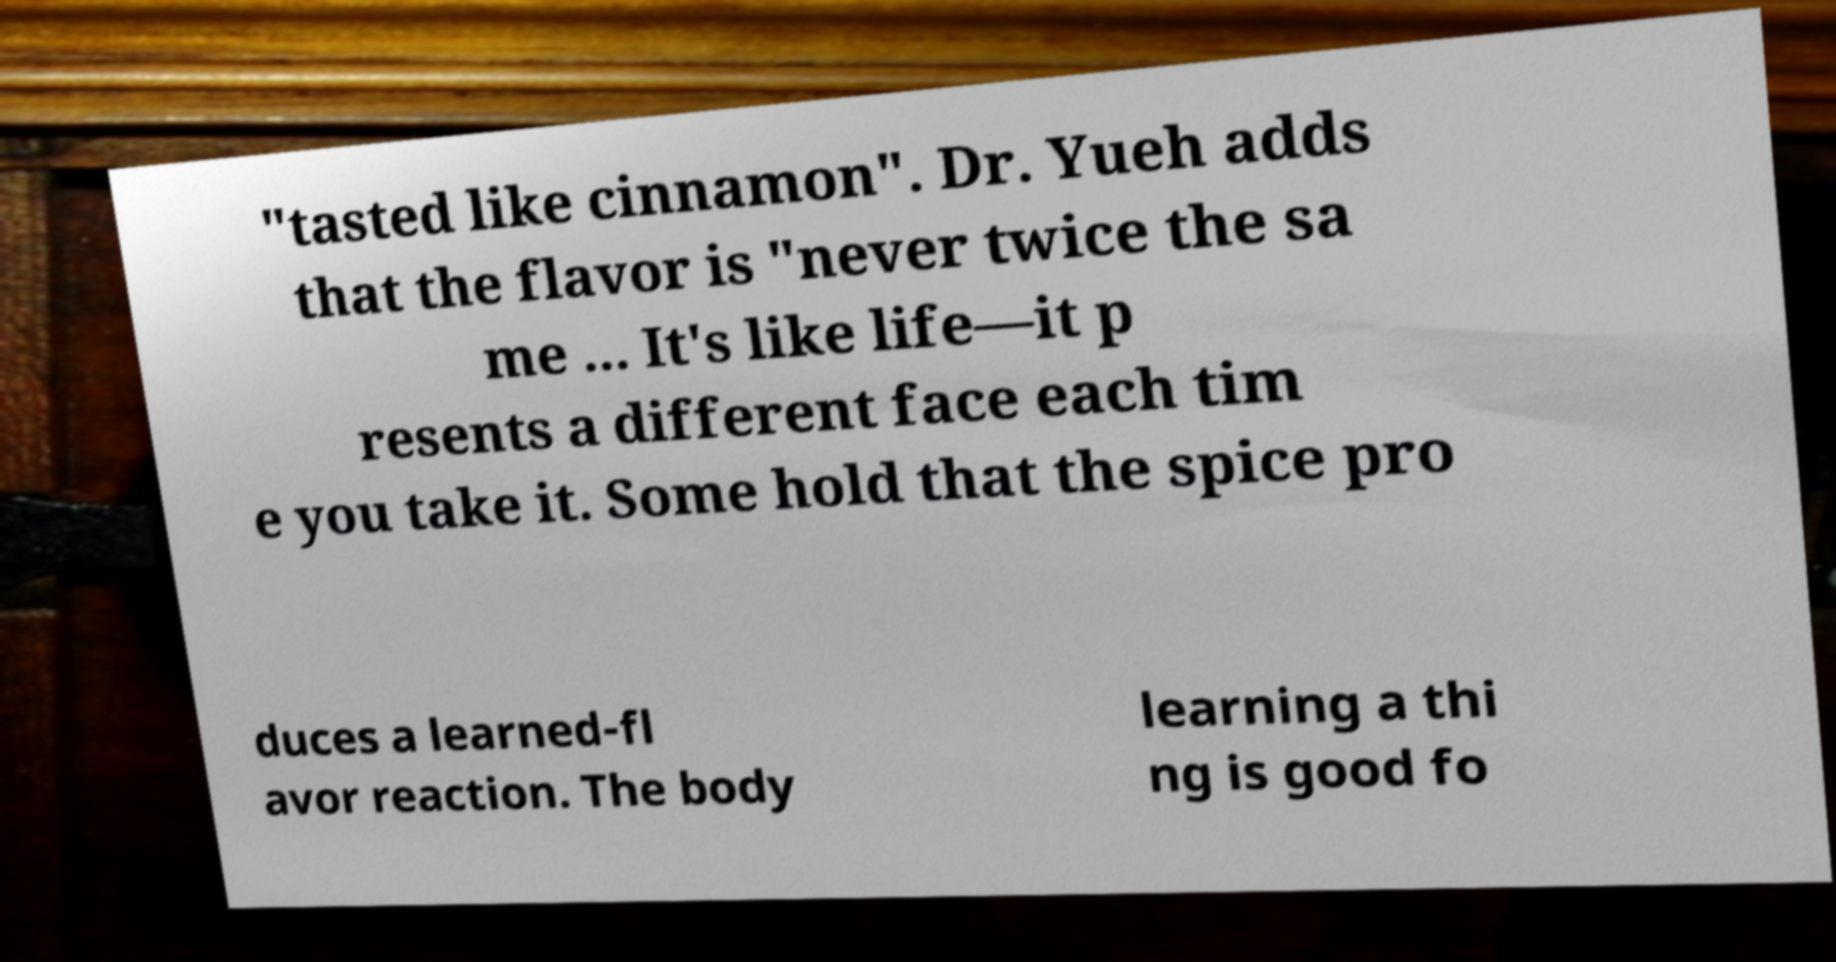What messages or text are displayed in this image? I need them in a readable, typed format. "tasted like cinnamon". Dr. Yueh adds that the flavor is "never twice the sa me ... It's like life—it p resents a different face each tim e you take it. Some hold that the spice pro duces a learned-fl avor reaction. The body learning a thi ng is good fo 